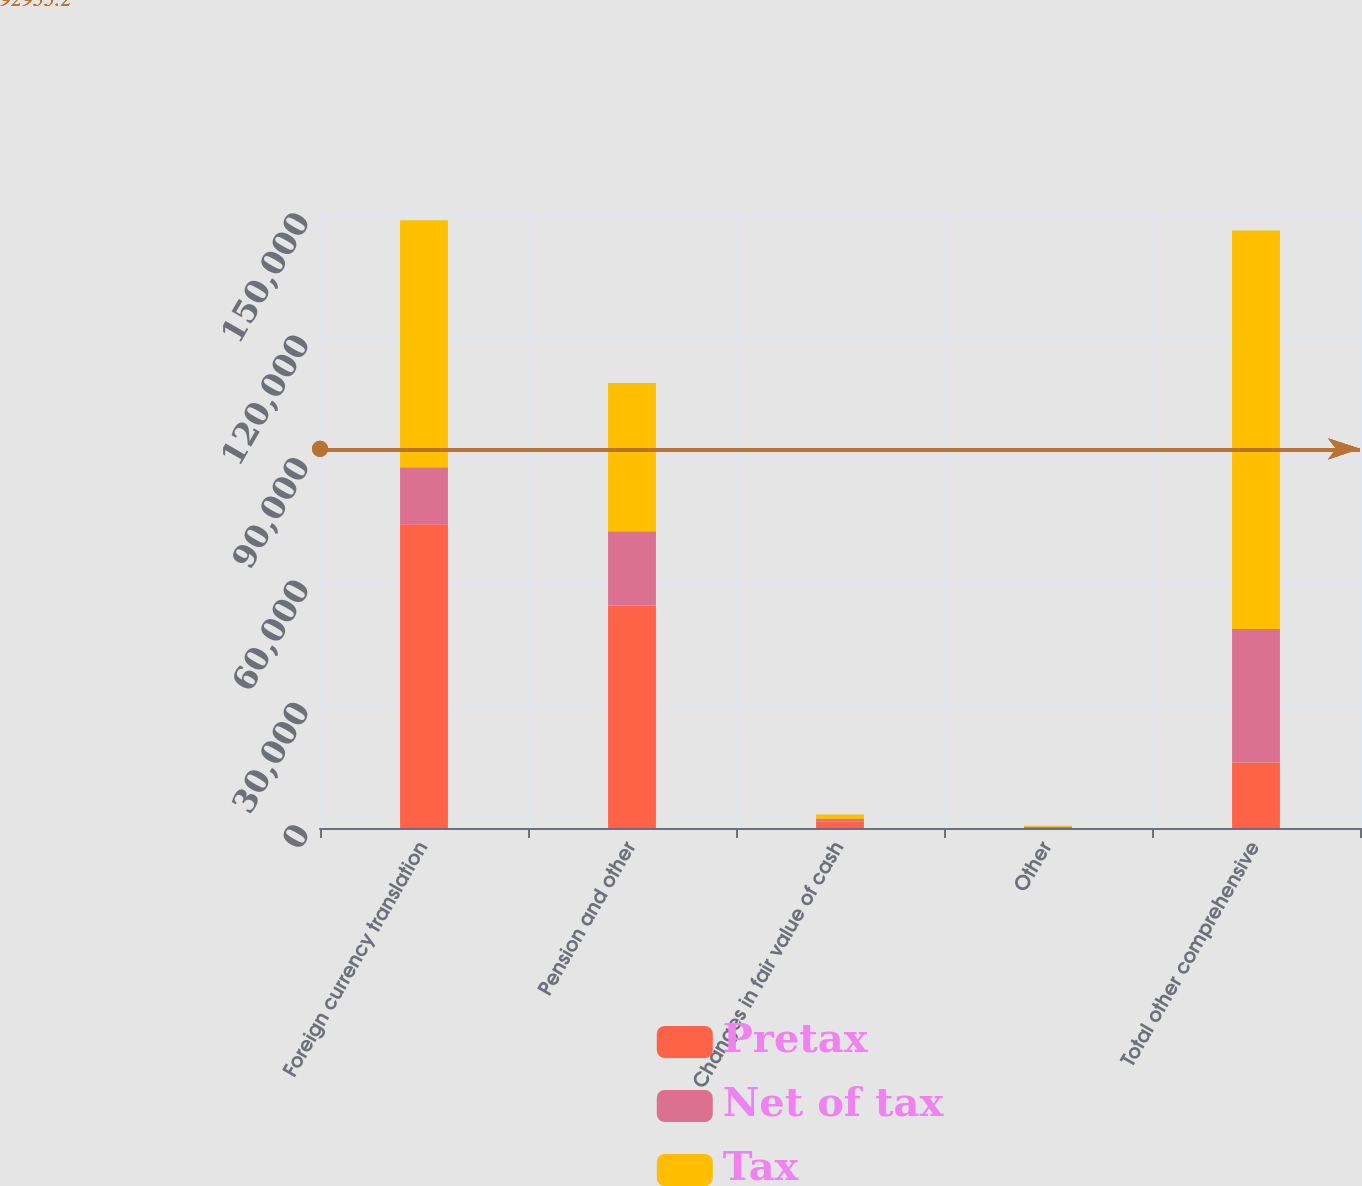Convert chart. <chart><loc_0><loc_0><loc_500><loc_500><stacked_bar_chart><ecel><fcel>Foreign currency translation<fcel>Pension and other<fcel>Changes in fair value of cash<fcel>Other<fcel>Total other comprehensive<nl><fcel>Pretax<fcel>74476<fcel>54519<fcel>1649<fcel>270<fcel>16079<nl><fcel>Net of tax<fcel>13954<fcel>18204<fcel>577<fcel>32<fcel>32703<nl><fcel>Tax<fcel>60522<fcel>36315<fcel>1072<fcel>238<fcel>97671<nl></chart> 